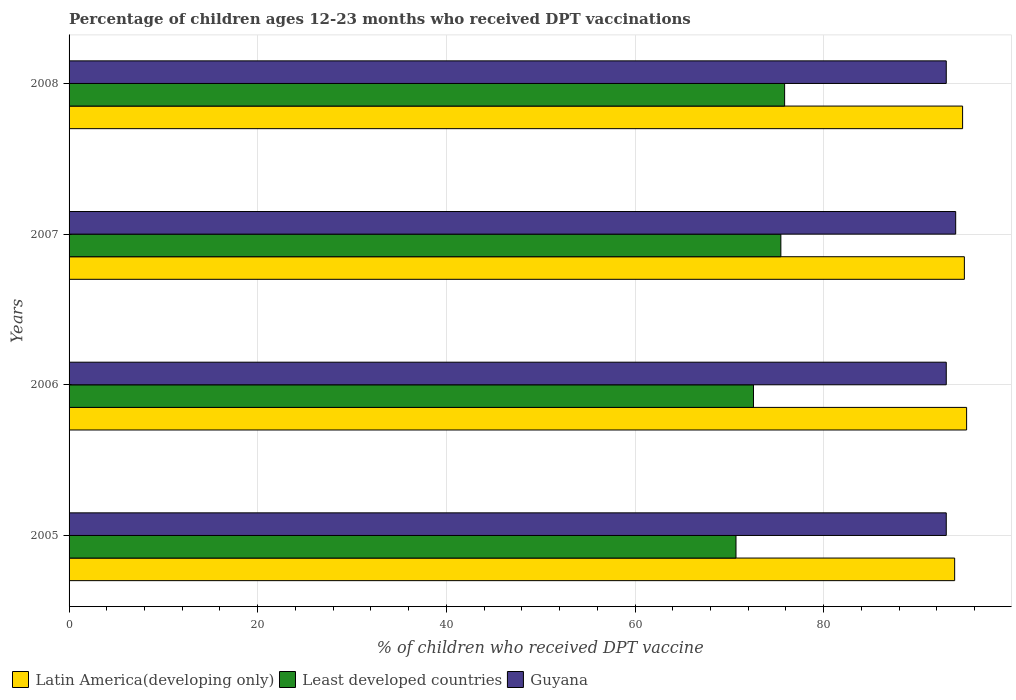Are the number of bars per tick equal to the number of legend labels?
Offer a terse response. Yes. Are the number of bars on each tick of the Y-axis equal?
Make the answer very short. Yes. How many bars are there on the 2nd tick from the top?
Your response must be concise. 3. How many bars are there on the 3rd tick from the bottom?
Give a very brief answer. 3. What is the label of the 3rd group of bars from the top?
Give a very brief answer. 2006. In how many cases, is the number of bars for a given year not equal to the number of legend labels?
Your response must be concise. 0. What is the percentage of children who received DPT vaccination in Least developed countries in 2006?
Provide a short and direct response. 72.56. Across all years, what is the maximum percentage of children who received DPT vaccination in Latin America(developing only)?
Keep it short and to the point. 95.16. Across all years, what is the minimum percentage of children who received DPT vaccination in Least developed countries?
Your answer should be very brief. 70.71. In which year was the percentage of children who received DPT vaccination in Guyana maximum?
Your answer should be compact. 2007. In which year was the percentage of children who received DPT vaccination in Latin America(developing only) minimum?
Your answer should be compact. 2005. What is the total percentage of children who received DPT vaccination in Latin America(developing only) in the graph?
Make the answer very short. 378.7. What is the difference between the percentage of children who received DPT vaccination in Latin America(developing only) in 2007 and that in 2008?
Your answer should be very brief. 0.19. What is the difference between the percentage of children who received DPT vaccination in Least developed countries in 2006 and the percentage of children who received DPT vaccination in Latin America(developing only) in 2007?
Your response must be concise. -22.36. What is the average percentage of children who received DPT vaccination in Guyana per year?
Offer a terse response. 93.25. In the year 2005, what is the difference between the percentage of children who received DPT vaccination in Latin America(developing only) and percentage of children who received DPT vaccination in Guyana?
Ensure brevity in your answer.  0.89. In how many years, is the percentage of children who received DPT vaccination in Least developed countries greater than 28 %?
Your answer should be very brief. 4. Is the percentage of children who received DPT vaccination in Guyana in 2005 less than that in 2008?
Make the answer very short. No. What is the difference between the highest and the second highest percentage of children who received DPT vaccination in Latin America(developing only)?
Provide a succinct answer. 0.24. What is the difference between the highest and the lowest percentage of children who received DPT vaccination in Latin America(developing only)?
Your answer should be very brief. 1.27. In how many years, is the percentage of children who received DPT vaccination in Least developed countries greater than the average percentage of children who received DPT vaccination in Least developed countries taken over all years?
Your response must be concise. 2. Is the sum of the percentage of children who received DPT vaccination in Guyana in 2007 and 2008 greater than the maximum percentage of children who received DPT vaccination in Latin America(developing only) across all years?
Your answer should be very brief. Yes. What does the 2nd bar from the top in 2008 represents?
Provide a short and direct response. Least developed countries. What does the 3rd bar from the bottom in 2007 represents?
Keep it short and to the point. Guyana. How many bars are there?
Make the answer very short. 12. How many years are there in the graph?
Your answer should be very brief. 4. What is the title of the graph?
Ensure brevity in your answer.  Percentage of children ages 12-23 months who received DPT vaccinations. What is the label or title of the X-axis?
Your answer should be compact. % of children who received DPT vaccine. What is the % of children who received DPT vaccine of Latin America(developing only) in 2005?
Your answer should be compact. 93.89. What is the % of children who received DPT vaccine in Least developed countries in 2005?
Provide a short and direct response. 70.71. What is the % of children who received DPT vaccine in Guyana in 2005?
Provide a short and direct response. 93. What is the % of children who received DPT vaccine in Latin America(developing only) in 2006?
Make the answer very short. 95.16. What is the % of children who received DPT vaccine in Least developed countries in 2006?
Your answer should be very brief. 72.56. What is the % of children who received DPT vaccine in Guyana in 2006?
Keep it short and to the point. 93. What is the % of children who received DPT vaccine in Latin America(developing only) in 2007?
Your answer should be very brief. 94.92. What is the % of children who received DPT vaccine of Least developed countries in 2007?
Offer a terse response. 75.46. What is the % of children who received DPT vaccine of Guyana in 2007?
Make the answer very short. 94. What is the % of children who received DPT vaccine in Latin America(developing only) in 2008?
Provide a succinct answer. 94.73. What is the % of children who received DPT vaccine in Least developed countries in 2008?
Ensure brevity in your answer.  75.86. What is the % of children who received DPT vaccine of Guyana in 2008?
Make the answer very short. 93. Across all years, what is the maximum % of children who received DPT vaccine in Latin America(developing only)?
Your response must be concise. 95.16. Across all years, what is the maximum % of children who received DPT vaccine in Least developed countries?
Your answer should be very brief. 75.86. Across all years, what is the maximum % of children who received DPT vaccine in Guyana?
Offer a very short reply. 94. Across all years, what is the minimum % of children who received DPT vaccine of Latin America(developing only)?
Ensure brevity in your answer.  93.89. Across all years, what is the minimum % of children who received DPT vaccine in Least developed countries?
Give a very brief answer. 70.71. Across all years, what is the minimum % of children who received DPT vaccine in Guyana?
Offer a very short reply. 93. What is the total % of children who received DPT vaccine of Latin America(developing only) in the graph?
Make the answer very short. 378.7. What is the total % of children who received DPT vaccine in Least developed countries in the graph?
Your answer should be very brief. 294.6. What is the total % of children who received DPT vaccine in Guyana in the graph?
Ensure brevity in your answer.  373. What is the difference between the % of children who received DPT vaccine in Latin America(developing only) in 2005 and that in 2006?
Give a very brief answer. -1.27. What is the difference between the % of children who received DPT vaccine in Least developed countries in 2005 and that in 2006?
Make the answer very short. -1.85. What is the difference between the % of children who received DPT vaccine in Guyana in 2005 and that in 2006?
Give a very brief answer. 0. What is the difference between the % of children who received DPT vaccine in Latin America(developing only) in 2005 and that in 2007?
Ensure brevity in your answer.  -1.03. What is the difference between the % of children who received DPT vaccine in Least developed countries in 2005 and that in 2007?
Ensure brevity in your answer.  -4.76. What is the difference between the % of children who received DPT vaccine of Latin America(developing only) in 2005 and that in 2008?
Keep it short and to the point. -0.84. What is the difference between the % of children who received DPT vaccine of Least developed countries in 2005 and that in 2008?
Provide a succinct answer. -5.16. What is the difference between the % of children who received DPT vaccine in Latin America(developing only) in 2006 and that in 2007?
Your response must be concise. 0.24. What is the difference between the % of children who received DPT vaccine in Least developed countries in 2006 and that in 2007?
Make the answer very short. -2.9. What is the difference between the % of children who received DPT vaccine of Latin America(developing only) in 2006 and that in 2008?
Your response must be concise. 0.43. What is the difference between the % of children who received DPT vaccine of Least developed countries in 2006 and that in 2008?
Provide a short and direct response. -3.3. What is the difference between the % of children who received DPT vaccine of Latin America(developing only) in 2007 and that in 2008?
Offer a terse response. 0.19. What is the difference between the % of children who received DPT vaccine in Least developed countries in 2007 and that in 2008?
Keep it short and to the point. -0.4. What is the difference between the % of children who received DPT vaccine of Guyana in 2007 and that in 2008?
Provide a succinct answer. 1. What is the difference between the % of children who received DPT vaccine of Latin America(developing only) in 2005 and the % of children who received DPT vaccine of Least developed countries in 2006?
Provide a short and direct response. 21.33. What is the difference between the % of children who received DPT vaccine of Latin America(developing only) in 2005 and the % of children who received DPT vaccine of Guyana in 2006?
Your answer should be compact. 0.89. What is the difference between the % of children who received DPT vaccine in Least developed countries in 2005 and the % of children who received DPT vaccine in Guyana in 2006?
Your answer should be compact. -22.29. What is the difference between the % of children who received DPT vaccine in Latin America(developing only) in 2005 and the % of children who received DPT vaccine in Least developed countries in 2007?
Give a very brief answer. 18.43. What is the difference between the % of children who received DPT vaccine in Latin America(developing only) in 2005 and the % of children who received DPT vaccine in Guyana in 2007?
Your answer should be compact. -0.11. What is the difference between the % of children who received DPT vaccine in Least developed countries in 2005 and the % of children who received DPT vaccine in Guyana in 2007?
Keep it short and to the point. -23.29. What is the difference between the % of children who received DPT vaccine of Latin America(developing only) in 2005 and the % of children who received DPT vaccine of Least developed countries in 2008?
Ensure brevity in your answer.  18.03. What is the difference between the % of children who received DPT vaccine of Latin America(developing only) in 2005 and the % of children who received DPT vaccine of Guyana in 2008?
Ensure brevity in your answer.  0.89. What is the difference between the % of children who received DPT vaccine in Least developed countries in 2005 and the % of children who received DPT vaccine in Guyana in 2008?
Keep it short and to the point. -22.29. What is the difference between the % of children who received DPT vaccine of Latin America(developing only) in 2006 and the % of children who received DPT vaccine of Least developed countries in 2007?
Ensure brevity in your answer.  19.69. What is the difference between the % of children who received DPT vaccine of Latin America(developing only) in 2006 and the % of children who received DPT vaccine of Guyana in 2007?
Provide a succinct answer. 1.16. What is the difference between the % of children who received DPT vaccine in Least developed countries in 2006 and the % of children who received DPT vaccine in Guyana in 2007?
Keep it short and to the point. -21.44. What is the difference between the % of children who received DPT vaccine of Latin America(developing only) in 2006 and the % of children who received DPT vaccine of Least developed countries in 2008?
Your answer should be compact. 19.29. What is the difference between the % of children who received DPT vaccine in Latin America(developing only) in 2006 and the % of children who received DPT vaccine in Guyana in 2008?
Keep it short and to the point. 2.16. What is the difference between the % of children who received DPT vaccine of Least developed countries in 2006 and the % of children who received DPT vaccine of Guyana in 2008?
Provide a short and direct response. -20.44. What is the difference between the % of children who received DPT vaccine in Latin America(developing only) in 2007 and the % of children who received DPT vaccine in Least developed countries in 2008?
Your answer should be compact. 19.06. What is the difference between the % of children who received DPT vaccine of Latin America(developing only) in 2007 and the % of children who received DPT vaccine of Guyana in 2008?
Your answer should be very brief. 1.92. What is the difference between the % of children who received DPT vaccine of Least developed countries in 2007 and the % of children who received DPT vaccine of Guyana in 2008?
Keep it short and to the point. -17.54. What is the average % of children who received DPT vaccine of Latin America(developing only) per year?
Offer a terse response. 94.68. What is the average % of children who received DPT vaccine of Least developed countries per year?
Offer a terse response. 73.65. What is the average % of children who received DPT vaccine of Guyana per year?
Ensure brevity in your answer.  93.25. In the year 2005, what is the difference between the % of children who received DPT vaccine of Latin America(developing only) and % of children who received DPT vaccine of Least developed countries?
Your response must be concise. 23.18. In the year 2005, what is the difference between the % of children who received DPT vaccine of Latin America(developing only) and % of children who received DPT vaccine of Guyana?
Ensure brevity in your answer.  0.89. In the year 2005, what is the difference between the % of children who received DPT vaccine of Least developed countries and % of children who received DPT vaccine of Guyana?
Give a very brief answer. -22.29. In the year 2006, what is the difference between the % of children who received DPT vaccine in Latin America(developing only) and % of children who received DPT vaccine in Least developed countries?
Your answer should be compact. 22.6. In the year 2006, what is the difference between the % of children who received DPT vaccine in Latin America(developing only) and % of children who received DPT vaccine in Guyana?
Provide a succinct answer. 2.16. In the year 2006, what is the difference between the % of children who received DPT vaccine in Least developed countries and % of children who received DPT vaccine in Guyana?
Your answer should be compact. -20.44. In the year 2007, what is the difference between the % of children who received DPT vaccine of Latin America(developing only) and % of children who received DPT vaccine of Least developed countries?
Offer a very short reply. 19.46. In the year 2007, what is the difference between the % of children who received DPT vaccine in Latin America(developing only) and % of children who received DPT vaccine in Guyana?
Your answer should be very brief. 0.92. In the year 2007, what is the difference between the % of children who received DPT vaccine of Least developed countries and % of children who received DPT vaccine of Guyana?
Offer a terse response. -18.54. In the year 2008, what is the difference between the % of children who received DPT vaccine in Latin America(developing only) and % of children who received DPT vaccine in Least developed countries?
Make the answer very short. 18.87. In the year 2008, what is the difference between the % of children who received DPT vaccine in Latin America(developing only) and % of children who received DPT vaccine in Guyana?
Your answer should be very brief. 1.73. In the year 2008, what is the difference between the % of children who received DPT vaccine of Least developed countries and % of children who received DPT vaccine of Guyana?
Ensure brevity in your answer.  -17.14. What is the ratio of the % of children who received DPT vaccine in Latin America(developing only) in 2005 to that in 2006?
Your answer should be compact. 0.99. What is the ratio of the % of children who received DPT vaccine in Least developed countries in 2005 to that in 2006?
Your response must be concise. 0.97. What is the ratio of the % of children who received DPT vaccine of Latin America(developing only) in 2005 to that in 2007?
Offer a terse response. 0.99. What is the ratio of the % of children who received DPT vaccine in Least developed countries in 2005 to that in 2007?
Your answer should be compact. 0.94. What is the ratio of the % of children who received DPT vaccine of Guyana in 2005 to that in 2007?
Provide a short and direct response. 0.99. What is the ratio of the % of children who received DPT vaccine of Least developed countries in 2005 to that in 2008?
Your answer should be compact. 0.93. What is the ratio of the % of children who received DPT vaccine in Guyana in 2005 to that in 2008?
Provide a succinct answer. 1. What is the ratio of the % of children who received DPT vaccine of Latin America(developing only) in 2006 to that in 2007?
Provide a short and direct response. 1. What is the ratio of the % of children who received DPT vaccine of Least developed countries in 2006 to that in 2007?
Your response must be concise. 0.96. What is the ratio of the % of children who received DPT vaccine of Guyana in 2006 to that in 2007?
Offer a terse response. 0.99. What is the ratio of the % of children who received DPT vaccine in Latin America(developing only) in 2006 to that in 2008?
Your response must be concise. 1. What is the ratio of the % of children who received DPT vaccine of Least developed countries in 2006 to that in 2008?
Your answer should be compact. 0.96. What is the ratio of the % of children who received DPT vaccine in Guyana in 2006 to that in 2008?
Provide a succinct answer. 1. What is the ratio of the % of children who received DPT vaccine in Latin America(developing only) in 2007 to that in 2008?
Your answer should be very brief. 1. What is the ratio of the % of children who received DPT vaccine of Least developed countries in 2007 to that in 2008?
Give a very brief answer. 0.99. What is the ratio of the % of children who received DPT vaccine in Guyana in 2007 to that in 2008?
Your answer should be compact. 1.01. What is the difference between the highest and the second highest % of children who received DPT vaccine in Latin America(developing only)?
Ensure brevity in your answer.  0.24. What is the difference between the highest and the second highest % of children who received DPT vaccine of Least developed countries?
Provide a succinct answer. 0.4. What is the difference between the highest and the second highest % of children who received DPT vaccine in Guyana?
Offer a terse response. 1. What is the difference between the highest and the lowest % of children who received DPT vaccine of Latin America(developing only)?
Offer a very short reply. 1.27. What is the difference between the highest and the lowest % of children who received DPT vaccine in Least developed countries?
Make the answer very short. 5.16. 